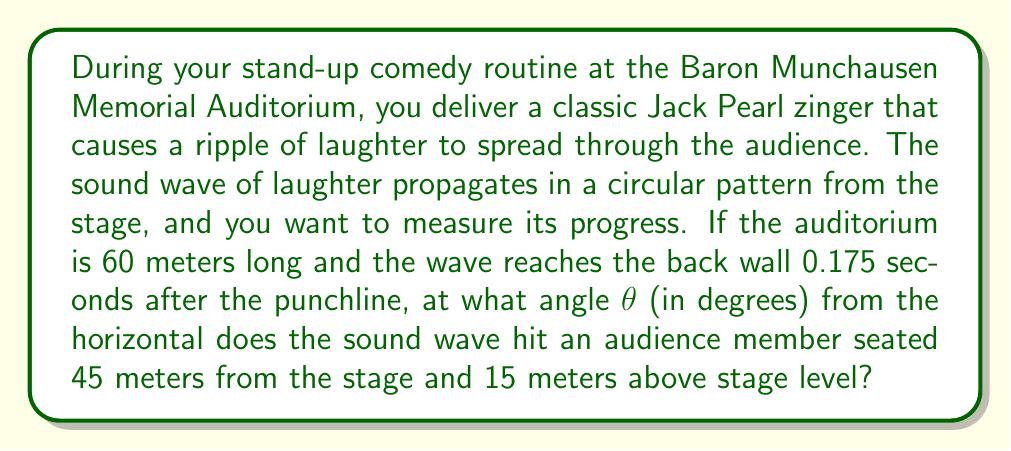What is the answer to this math problem? Let's approach this step-by-step:

1) First, we need to calculate the speed of sound in the auditorium:
   Distance = 60 meters
   Time = 0.175 seconds
   Speed = Distance / Time = 60 / 0.175 = 342.86 m/s

2) Now, let's consider the right triangle formed by:
   - The horizontal distance to the audience member (45 m)
   - The vertical height of the audience member (15 m)
   - The hypotenuse (path of the sound wave)

3) We can find the length of the hypotenuse using the Pythagorean theorem:
   $$c^2 = a^2 + b^2$$
   $$c^2 = 45^2 + 15^2 = 2025 + 225 = 2250$$
   $$c = \sqrt{2250} = 47.43 \text{ meters}$$

4) Now we know the distance the sound travels to reach the audience member.
   We can calculate the time it takes:
   Time = Distance / Speed = 47.43 / 342.86 = 0.1383 seconds

5) To find the angle θ, we can use the arctangent function:
   $$\theta = \arctan(\frac{\text{opposite}}{\text{adjacent}}) = \arctan(\frac{15}{45})$$

6) Calculating this:
   $$\theta = \arctan(0.3333) = 18.43 \text{ degrees}$$

Thus, the sound wave hits the audience member at an angle of approximately 18.43 degrees from the horizontal.
Answer: $18.43°$ 